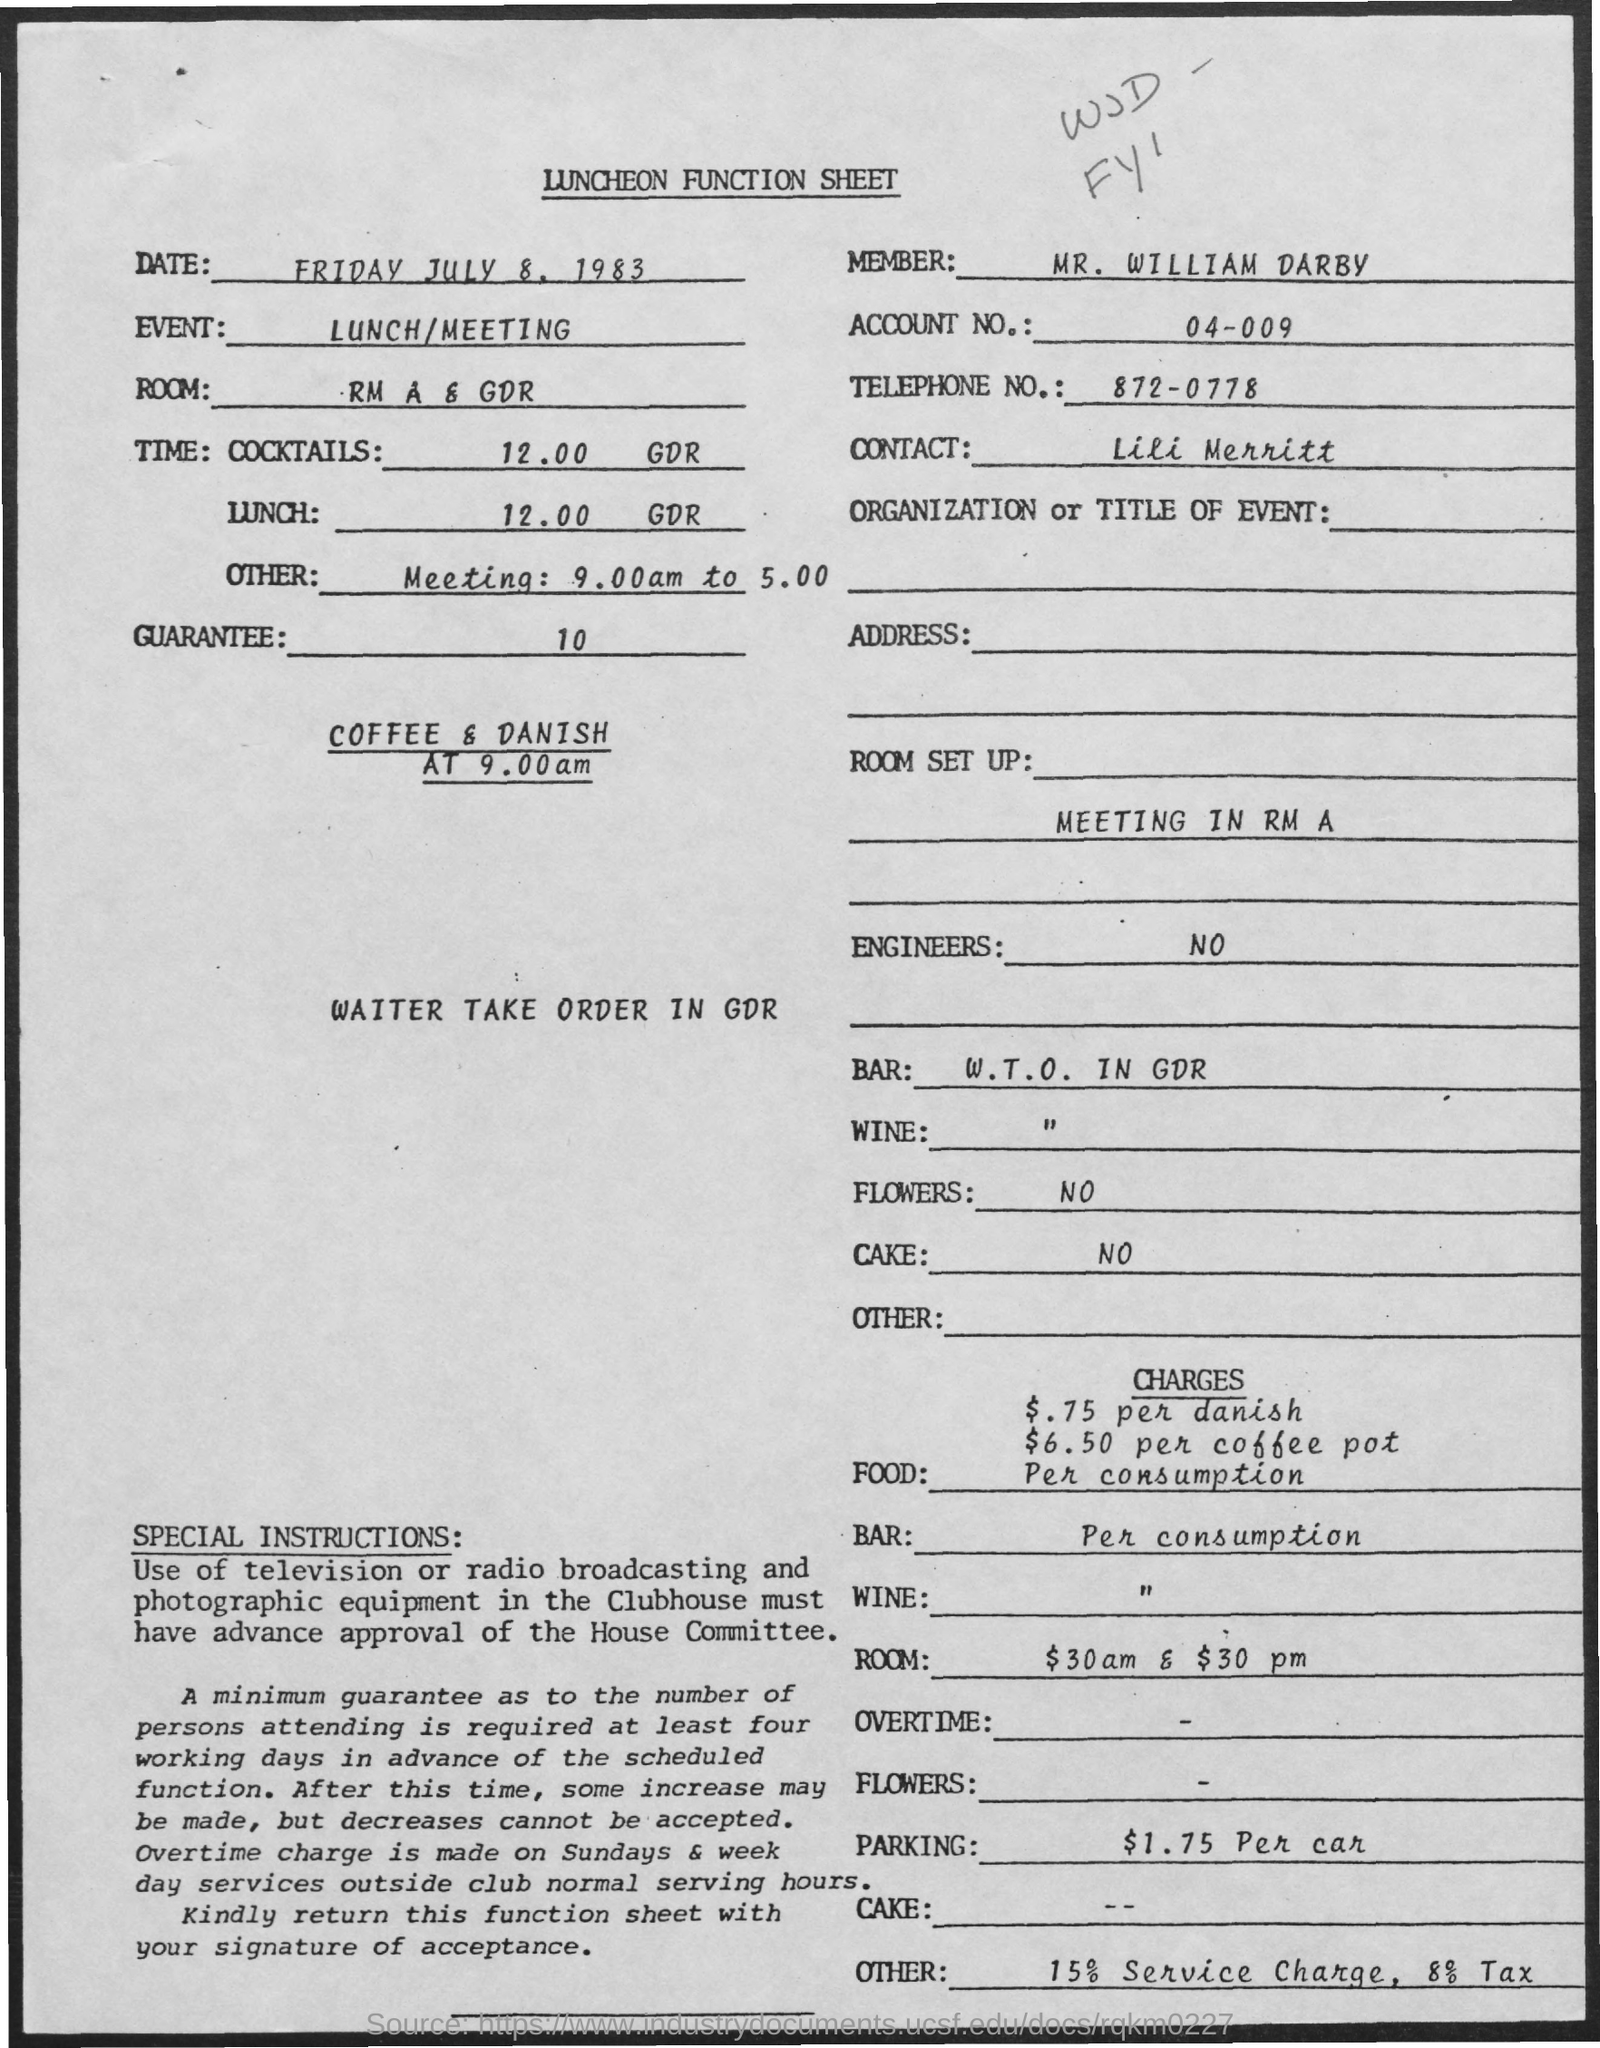Who is the member as mentioned in this document?
Provide a succinct answer. Mr. William Darby. What is the Event mentioned in this document?
Provide a succinct answer. LUNCH/MEETING. What is the account no mentioned in this document?
Provide a short and direct response. 04-009. What is the Telephone No given in this document?
Ensure brevity in your answer.  872-0778. Who is the Contact person as per the document?
Ensure brevity in your answer.  LILI MERRITT. What is the charge for parking facility as per the document?
Offer a terse response. $1.75 Per car. 